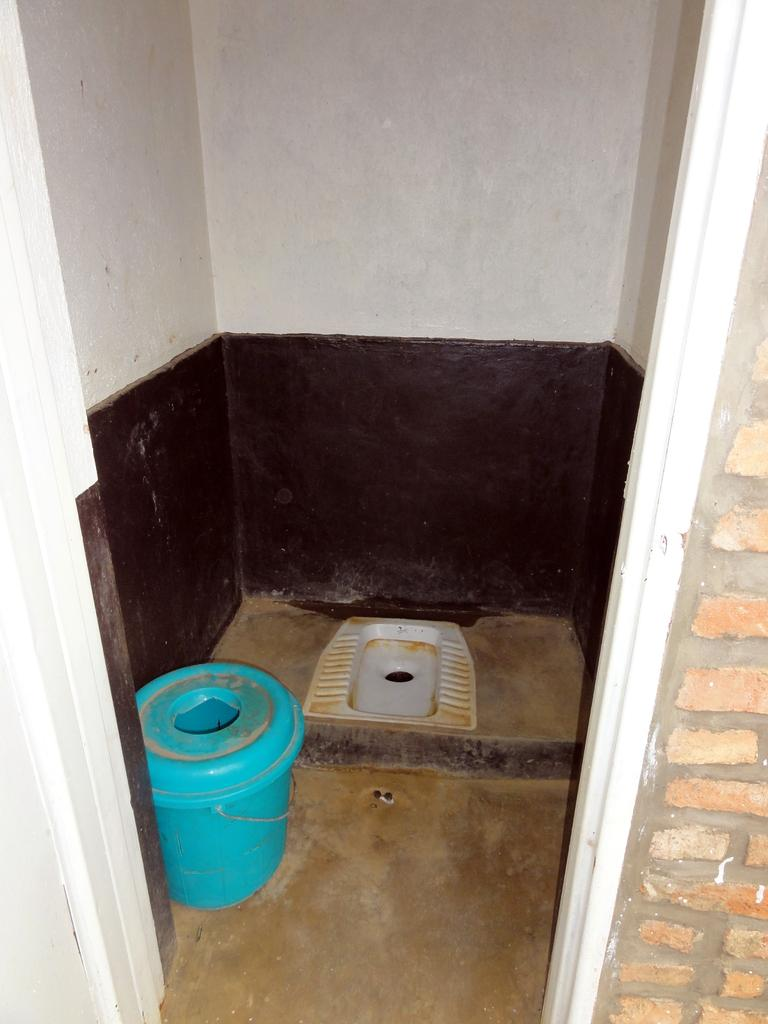What is the main object in the center of the image? There is a toilet seat and a bucket in the center of the image. What can be seen on the floor in the image? The floor is visible in the image. What is visible in the background of the image? There is a wall and a door in the background of the image. What type of popcorn is being served in the afternoon in the image? There is no popcorn or reference to an afternoon in the image. 